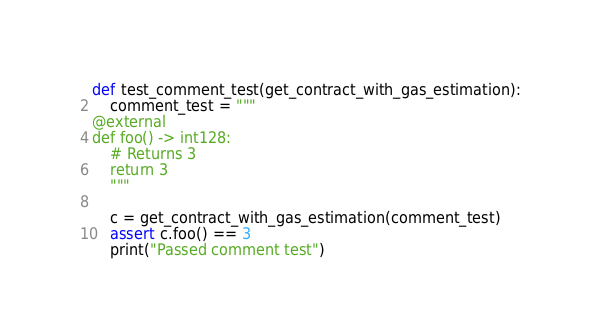<code> <loc_0><loc_0><loc_500><loc_500><_Python_>def test_comment_test(get_contract_with_gas_estimation):
    comment_test = """
@external
def foo() -> int128:
    # Returns 3
    return 3
    """

    c = get_contract_with_gas_estimation(comment_test)
    assert c.foo() == 3
    print("Passed comment test")
</code> 